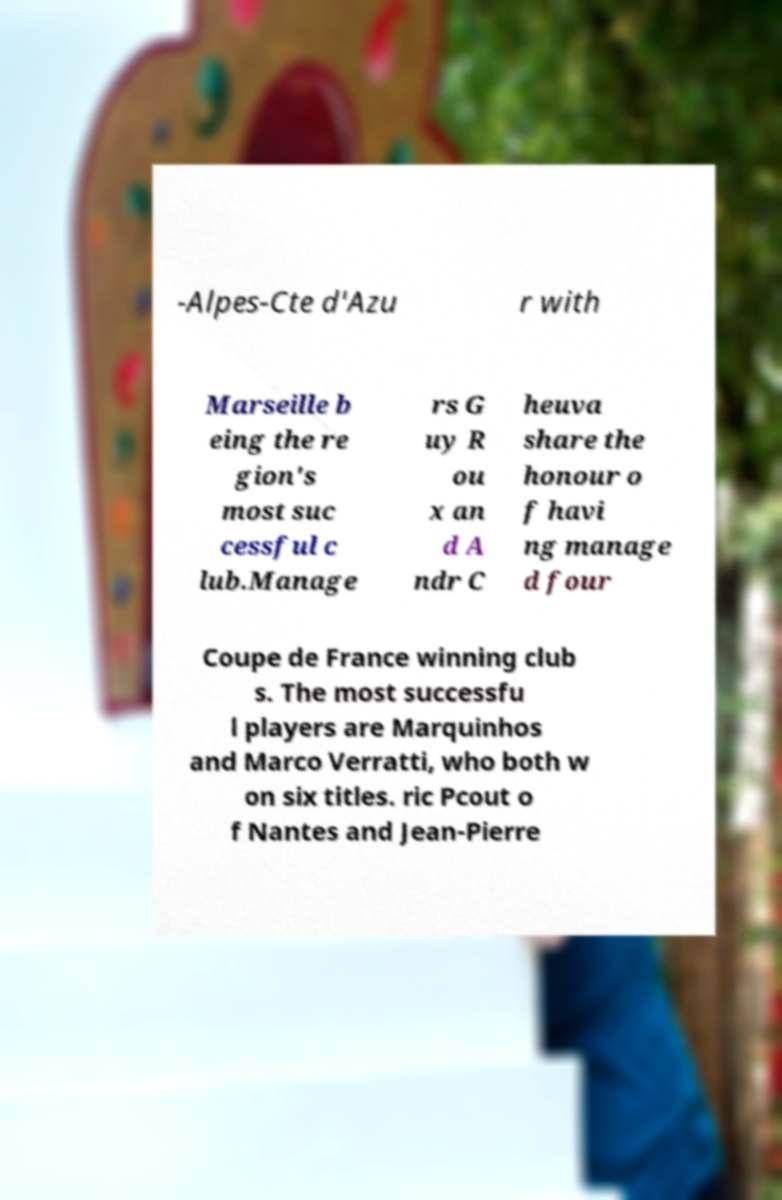Could you extract and type out the text from this image? -Alpes-Cte d'Azu r with Marseille b eing the re gion's most suc cessful c lub.Manage rs G uy R ou x an d A ndr C heuva share the honour o f havi ng manage d four Coupe de France winning club s. The most successfu l players are Marquinhos and Marco Verratti, who both w on six titles. ric Pcout o f Nantes and Jean-Pierre 